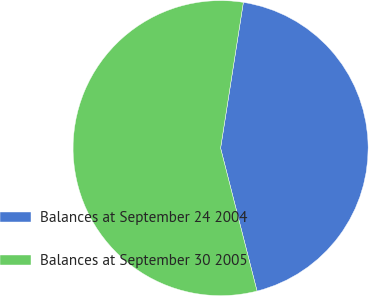Convert chart. <chart><loc_0><loc_0><loc_500><loc_500><pie_chart><fcel>Balances at September 24 2004<fcel>Balances at September 30 2005<nl><fcel>43.56%<fcel>56.44%<nl></chart> 